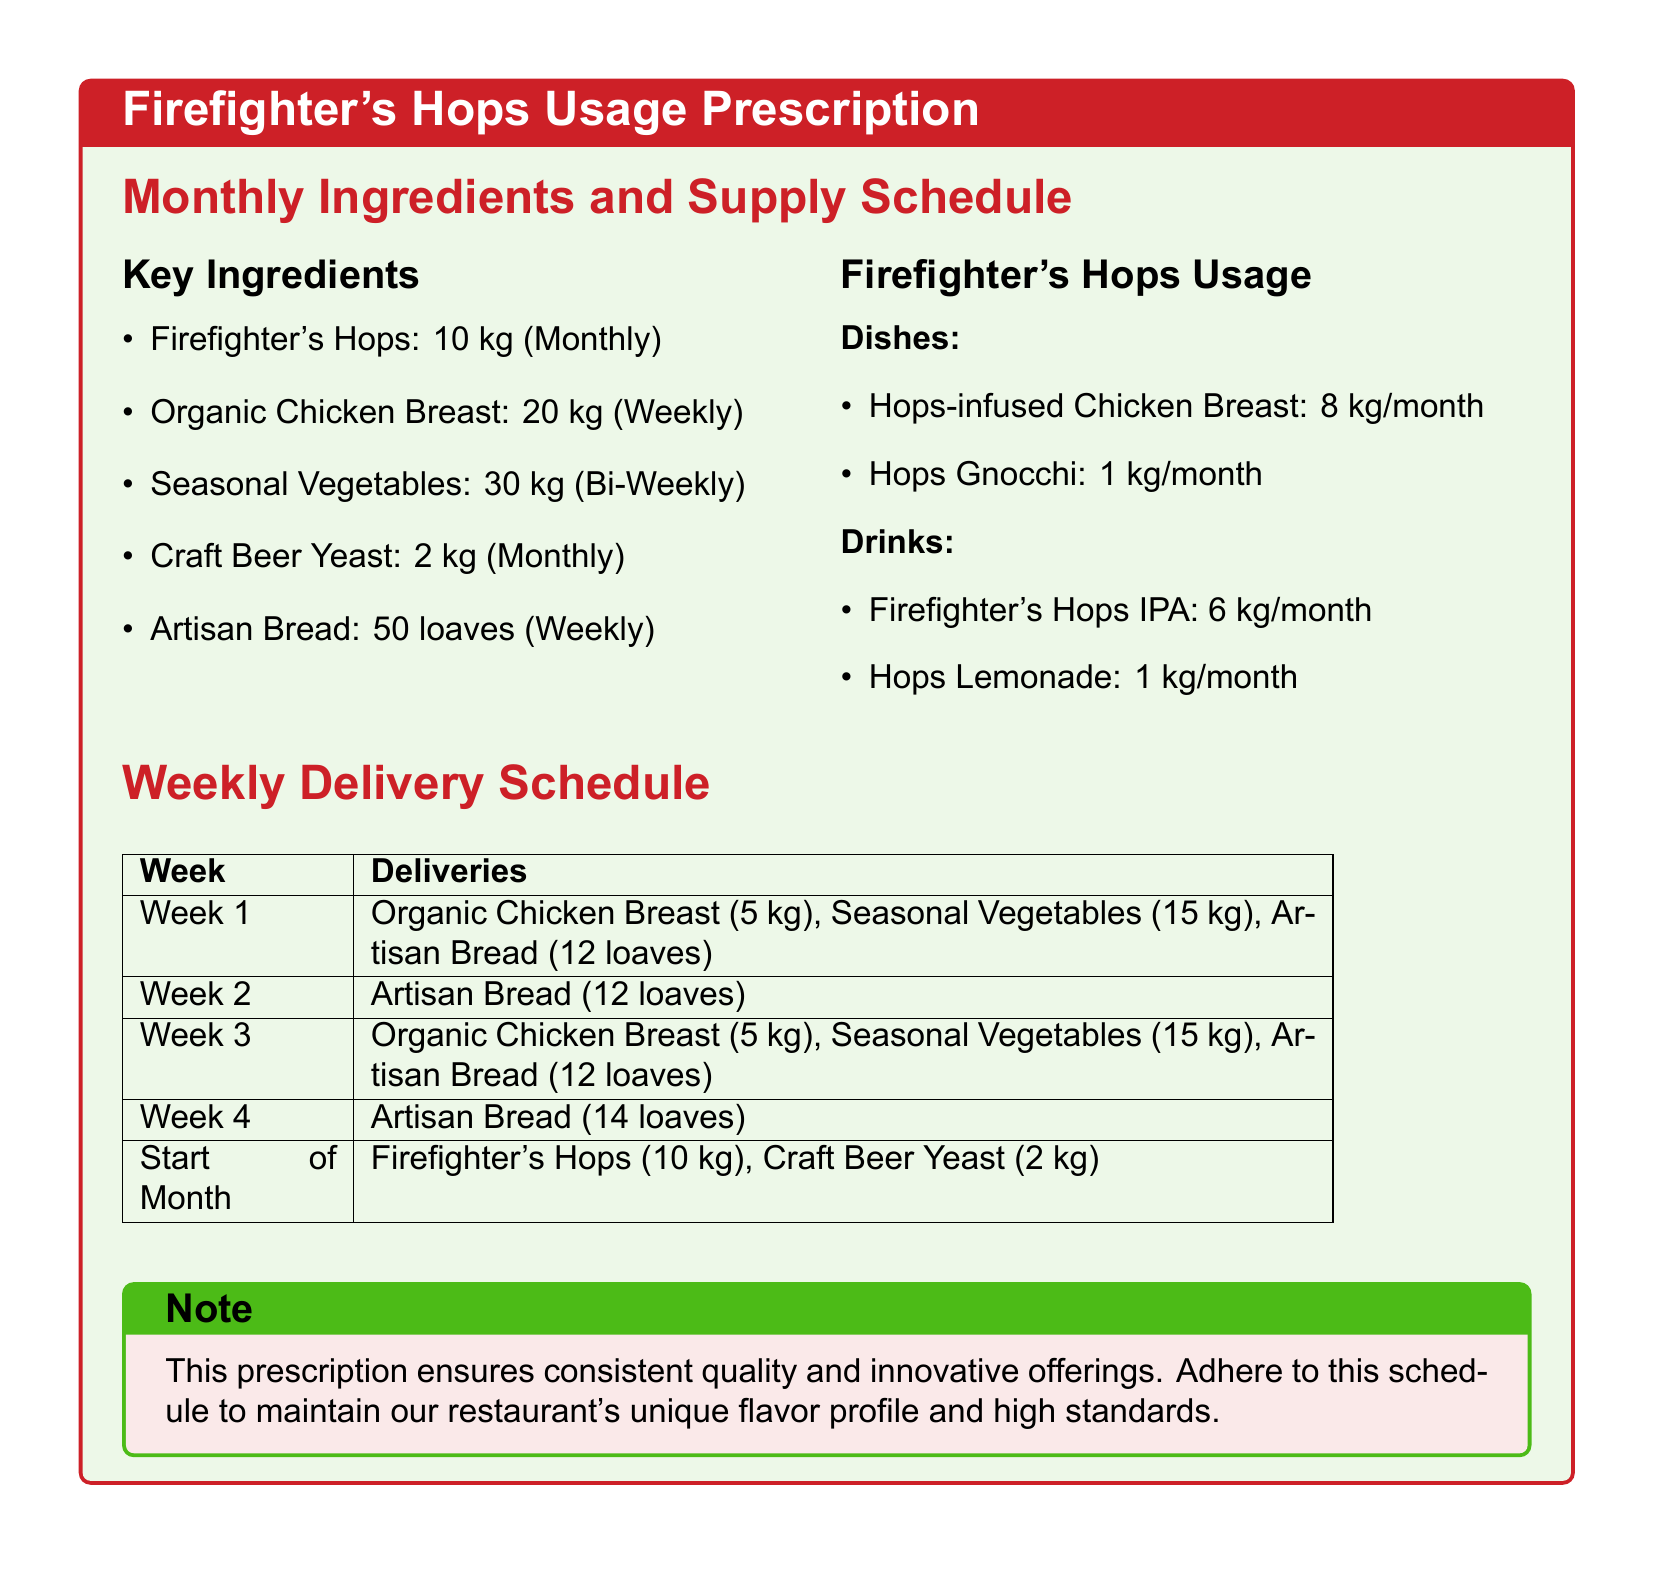what is the monthly supply of Firefighter's Hops? The document states that the monthly supply of Firefighter's Hops is 10 kg.
Answer: 10 kg how much Organic Chicken Breast is supplied weekly? The weekly supply of Organic Chicken Breast is mentioned as 20 kg.
Answer: 20 kg what dish uses 8 kg of Firefighter's Hops per month? The dish that uses 8 kg of Firefighter's Hops per month is Hops-infused Chicken Breast.
Answer: Hops-infused Chicken Breast how many loaves of Artisan Bread are delivered in Week 1? The document specifies that 12 loaves of Artisan Bread are delivered in Week 1.
Answer: 12 loaves what is the total monthly usage of Hops in drinks? The total monthly usage of Hops in drinks is the sum of the amounts used for Firefighter's Hops IPA and Hops Lemonade, which is 6 kg + 1 kg = 7 kg.
Answer: 7 kg how many kg of Seasonal Vegetables are supplied every two weeks? The document notes that Seasonal Vegetables are supplied 30 kg every bi-weekly.
Answer: 30 kg which item is delivered at the start of the month? The items delivered at the start of the month are Firefighter's Hops and Craft Beer Yeast.
Answer: Firefighter's Hops, Craft Beer Yeast how many kg of Hops are used in Hops Gnocchi each month? The monthly usage for Hops Gnocchi is stated as 1 kg.
Answer: 1 kg what color is used for the title in the document? The title in the document uses the color firefighterred.
Answer: firefighterred 